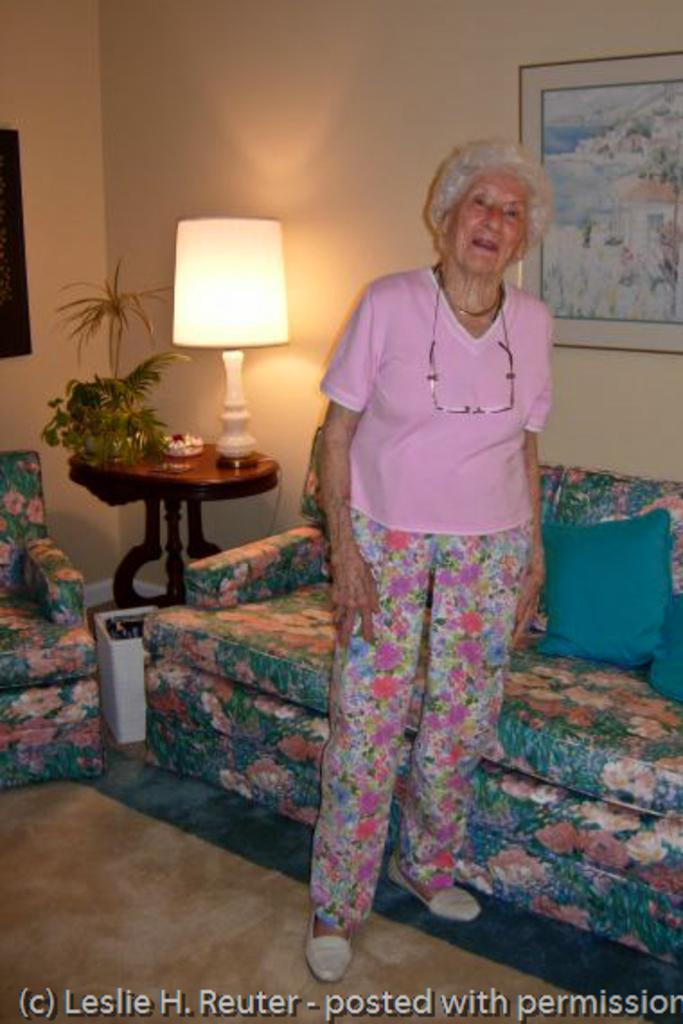How would you summarize this image in a sentence or two? There is a woman standing on the floor. These are the sofas. This is table. On the table there is a lamp and this is plant. On the background there is a wall and this is frame. 